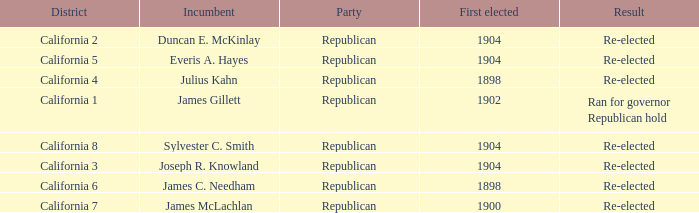Which District has a First Elected of 1904 and an Incumbent of Duncan E. Mckinlay? California 2. 